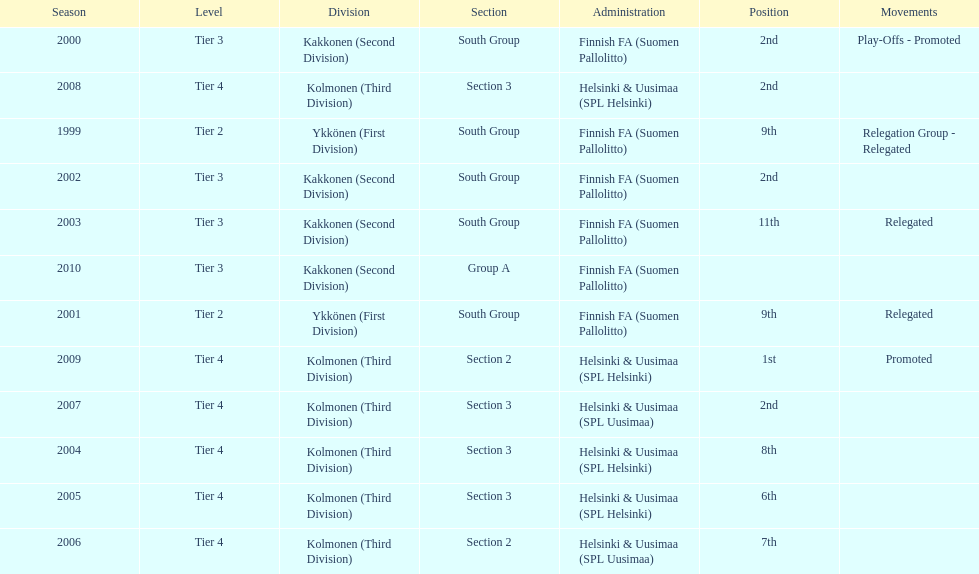Give me the full table as a dictionary. {'header': ['Season', 'Level', 'Division', 'Section', 'Administration', 'Position', 'Movements'], 'rows': [['2000', 'Tier 3', 'Kakkonen (Second Division)', 'South Group', 'Finnish FA (Suomen Pallolitto)', '2nd', 'Play-Offs - Promoted'], ['2008', 'Tier 4', 'Kolmonen (Third Division)', 'Section 3', 'Helsinki & Uusimaa (SPL Helsinki)', '2nd', ''], ['1999', 'Tier 2', 'Ykkönen (First Division)', 'South Group', 'Finnish FA (Suomen Pallolitto)', '9th', 'Relegation Group - Relegated'], ['2002', 'Tier 3', 'Kakkonen (Second Division)', 'South Group', 'Finnish FA (Suomen Pallolitto)', '2nd', ''], ['2003', 'Tier 3', 'Kakkonen (Second Division)', 'South Group', 'Finnish FA (Suomen Pallolitto)', '11th', 'Relegated'], ['2010', 'Tier 3', 'Kakkonen (Second Division)', 'Group A', 'Finnish FA (Suomen Pallolitto)', '', ''], ['2001', 'Tier 2', 'Ykkönen (First Division)', 'South Group', 'Finnish FA (Suomen Pallolitto)', '9th', 'Relegated'], ['2009', 'Tier 4', 'Kolmonen (Third Division)', 'Section 2', 'Helsinki & Uusimaa (SPL Helsinki)', '1st', 'Promoted'], ['2007', 'Tier 4', 'Kolmonen (Third Division)', 'Section 3', 'Helsinki & Uusimaa (SPL Uusimaa)', '2nd', ''], ['2004', 'Tier 4', 'Kolmonen (Third Division)', 'Section 3', 'Helsinki & Uusimaa (SPL Helsinki)', '8th', ''], ['2005', 'Tier 4', 'Kolmonen (Third Division)', 'Section 3', 'Helsinki & Uusimaa (SPL Helsinki)', '6th', ''], ['2006', 'Tier 4', 'Kolmonen (Third Division)', 'Section 2', 'Helsinki & Uusimaa (SPL Uusimaa)', '7th', '']]} How many tiers had more than one relegated movement? 1. 